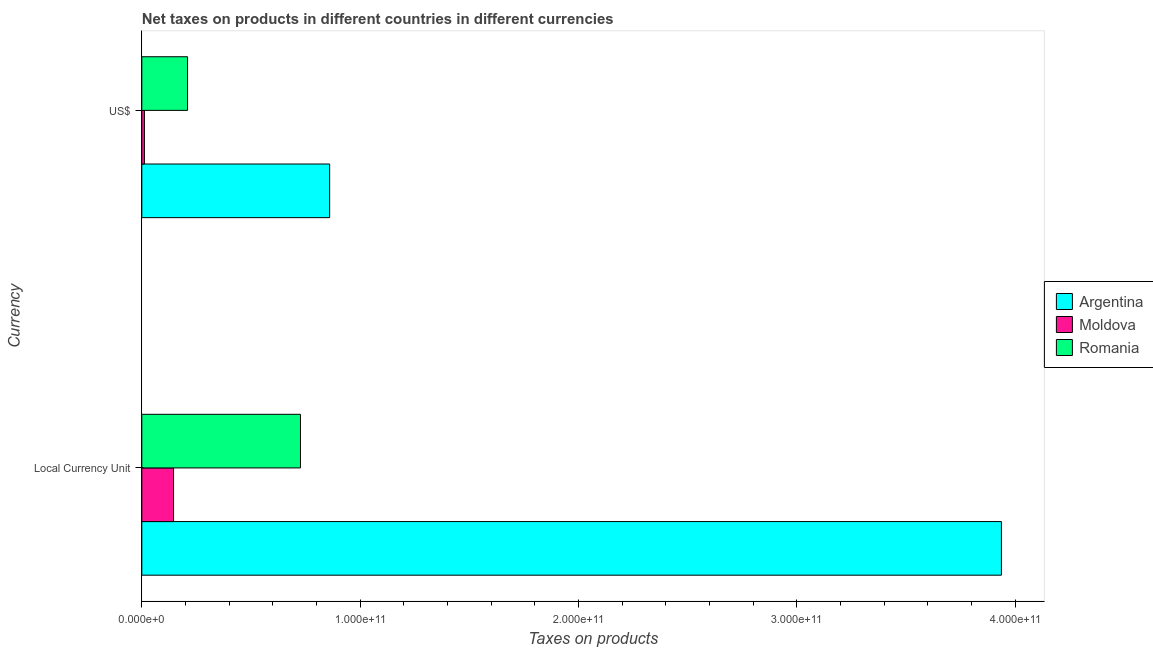Are the number of bars per tick equal to the number of legend labels?
Your answer should be very brief. Yes. How many bars are there on the 2nd tick from the top?
Your answer should be compact. 3. How many bars are there on the 2nd tick from the bottom?
Ensure brevity in your answer.  3. What is the label of the 1st group of bars from the top?
Make the answer very short. US$. What is the net taxes in constant 2005 us$ in Argentina?
Provide a short and direct response. 3.94e+11. Across all countries, what is the maximum net taxes in us$?
Offer a terse response. 8.60e+1. Across all countries, what is the minimum net taxes in us$?
Give a very brief answer. 1.20e+09. In which country was the net taxes in us$ minimum?
Make the answer very short. Moldova. What is the total net taxes in us$ in the graph?
Keep it short and to the point. 1.08e+11. What is the difference between the net taxes in us$ in Moldova and that in Romania?
Your answer should be compact. -1.98e+1. What is the difference between the net taxes in constant 2005 us$ in Moldova and the net taxes in us$ in Argentina?
Ensure brevity in your answer.  -7.15e+1. What is the average net taxes in constant 2005 us$ per country?
Provide a short and direct response. 1.60e+11. What is the difference between the net taxes in constant 2005 us$ and net taxes in us$ in Argentina?
Make the answer very short. 3.08e+11. What is the ratio of the net taxes in us$ in Argentina to that in Moldova?
Make the answer very short. 71.67. What does the 1st bar from the top in US$ represents?
Your response must be concise. Romania. What does the 2nd bar from the bottom in US$ represents?
Provide a succinct answer. Moldova. How many countries are there in the graph?
Offer a terse response. 3. What is the difference between two consecutive major ticks on the X-axis?
Offer a terse response. 1.00e+11. Are the values on the major ticks of X-axis written in scientific E-notation?
Offer a terse response. Yes. Does the graph contain grids?
Your response must be concise. No. How are the legend labels stacked?
Make the answer very short. Vertical. What is the title of the graph?
Ensure brevity in your answer.  Net taxes on products in different countries in different currencies. What is the label or title of the X-axis?
Your answer should be very brief. Taxes on products. What is the label or title of the Y-axis?
Ensure brevity in your answer.  Currency. What is the Taxes on products of Argentina in Local Currency Unit?
Give a very brief answer. 3.94e+11. What is the Taxes on products in Moldova in Local Currency Unit?
Keep it short and to the point. 1.45e+1. What is the Taxes on products in Romania in Local Currency Unit?
Offer a terse response. 7.27e+1. What is the Taxes on products in Argentina in US$?
Your response must be concise. 8.60e+1. What is the Taxes on products in Moldova in US$?
Offer a very short reply. 1.20e+09. What is the Taxes on products in Romania in US$?
Your response must be concise. 2.10e+1. Across all Currency, what is the maximum Taxes on products of Argentina?
Ensure brevity in your answer.  3.94e+11. Across all Currency, what is the maximum Taxes on products of Moldova?
Your answer should be compact. 1.45e+1. Across all Currency, what is the maximum Taxes on products of Romania?
Your response must be concise. 7.27e+1. Across all Currency, what is the minimum Taxes on products of Argentina?
Give a very brief answer. 8.60e+1. Across all Currency, what is the minimum Taxes on products in Moldova?
Ensure brevity in your answer.  1.20e+09. Across all Currency, what is the minimum Taxes on products in Romania?
Your answer should be very brief. 2.10e+1. What is the total Taxes on products in Argentina in the graph?
Offer a terse response. 4.80e+11. What is the total Taxes on products in Moldova in the graph?
Ensure brevity in your answer.  1.57e+1. What is the total Taxes on products of Romania in the graph?
Provide a succinct answer. 9.36e+1. What is the difference between the Taxes on products of Argentina in Local Currency Unit and that in US$?
Make the answer very short. 3.08e+11. What is the difference between the Taxes on products in Moldova in Local Currency Unit and that in US$?
Offer a very short reply. 1.33e+1. What is the difference between the Taxes on products of Romania in Local Currency Unit and that in US$?
Offer a terse response. 5.17e+1. What is the difference between the Taxes on products in Argentina in Local Currency Unit and the Taxes on products in Moldova in US$?
Give a very brief answer. 3.93e+11. What is the difference between the Taxes on products of Argentina in Local Currency Unit and the Taxes on products of Romania in US$?
Provide a succinct answer. 3.73e+11. What is the difference between the Taxes on products of Moldova in Local Currency Unit and the Taxes on products of Romania in US$?
Give a very brief answer. -6.41e+09. What is the average Taxes on products in Argentina per Currency?
Provide a short and direct response. 2.40e+11. What is the average Taxes on products in Moldova per Currency?
Ensure brevity in your answer.  7.87e+09. What is the average Taxes on products of Romania per Currency?
Provide a succinct answer. 4.68e+1. What is the difference between the Taxes on products in Argentina and Taxes on products in Moldova in Local Currency Unit?
Your response must be concise. 3.79e+11. What is the difference between the Taxes on products of Argentina and Taxes on products of Romania in Local Currency Unit?
Your response must be concise. 3.21e+11. What is the difference between the Taxes on products in Moldova and Taxes on products in Romania in Local Currency Unit?
Make the answer very short. -5.81e+1. What is the difference between the Taxes on products of Argentina and Taxes on products of Moldova in US$?
Give a very brief answer. 8.48e+1. What is the difference between the Taxes on products of Argentina and Taxes on products of Romania in US$?
Offer a terse response. 6.51e+1. What is the difference between the Taxes on products in Moldova and Taxes on products in Romania in US$?
Provide a succinct answer. -1.98e+1. What is the ratio of the Taxes on products of Argentina in Local Currency Unit to that in US$?
Make the answer very short. 4.58. What is the ratio of the Taxes on products in Moldova in Local Currency Unit to that in US$?
Provide a succinct answer. 12.11. What is the ratio of the Taxes on products in Romania in Local Currency Unit to that in US$?
Your answer should be very brief. 3.47. What is the difference between the highest and the second highest Taxes on products of Argentina?
Offer a terse response. 3.08e+11. What is the difference between the highest and the second highest Taxes on products of Moldova?
Ensure brevity in your answer.  1.33e+1. What is the difference between the highest and the second highest Taxes on products in Romania?
Offer a very short reply. 5.17e+1. What is the difference between the highest and the lowest Taxes on products of Argentina?
Your answer should be compact. 3.08e+11. What is the difference between the highest and the lowest Taxes on products of Moldova?
Keep it short and to the point. 1.33e+1. What is the difference between the highest and the lowest Taxes on products of Romania?
Your response must be concise. 5.17e+1. 